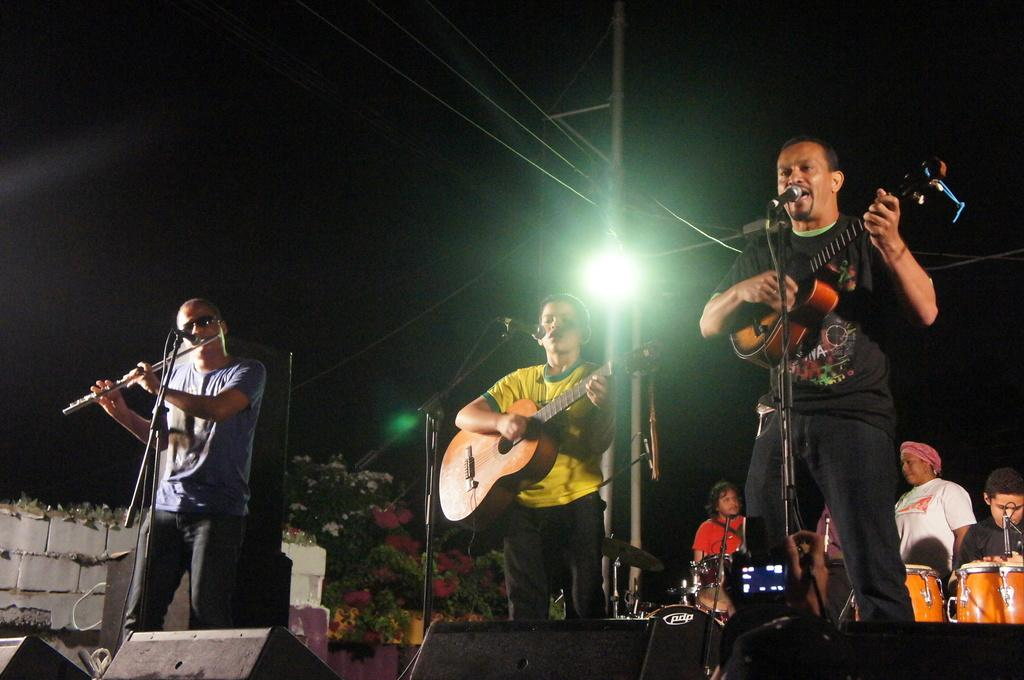How many people are in the image? There are three members in the image. Where are the members located in the image? The members are standing on a stage. What are the members doing in the image? The members are playing guitar. What is in front of the members on the stage? There is a microphone in front of the members. What type of flowers can be seen growing in the hole on the stage? There are no flowers or holes present on the stage in the image. 